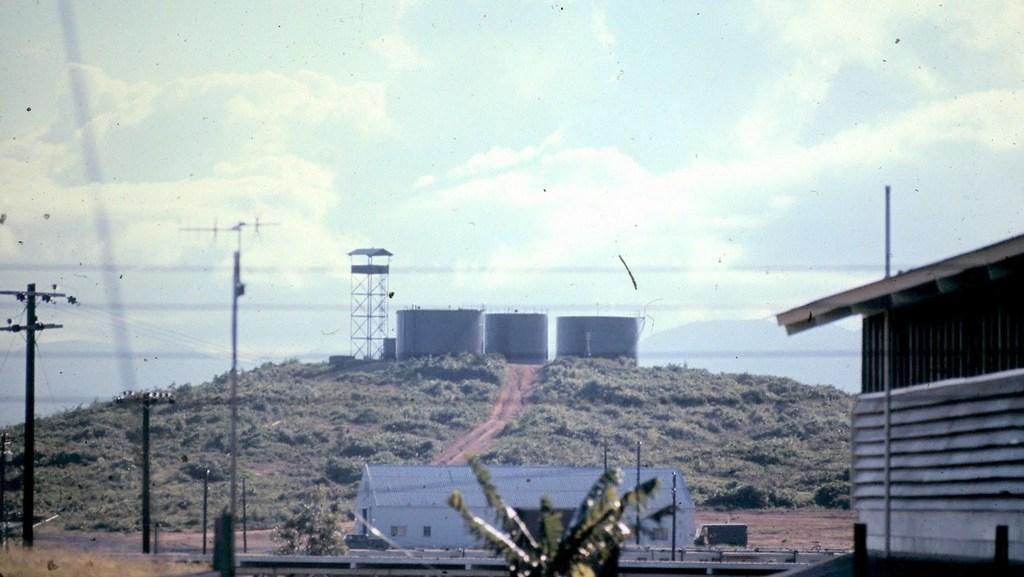How would you summarize this image in a sentence or two? In this image there are trees, shed, building,poles, containers, and in the background there is sky. 